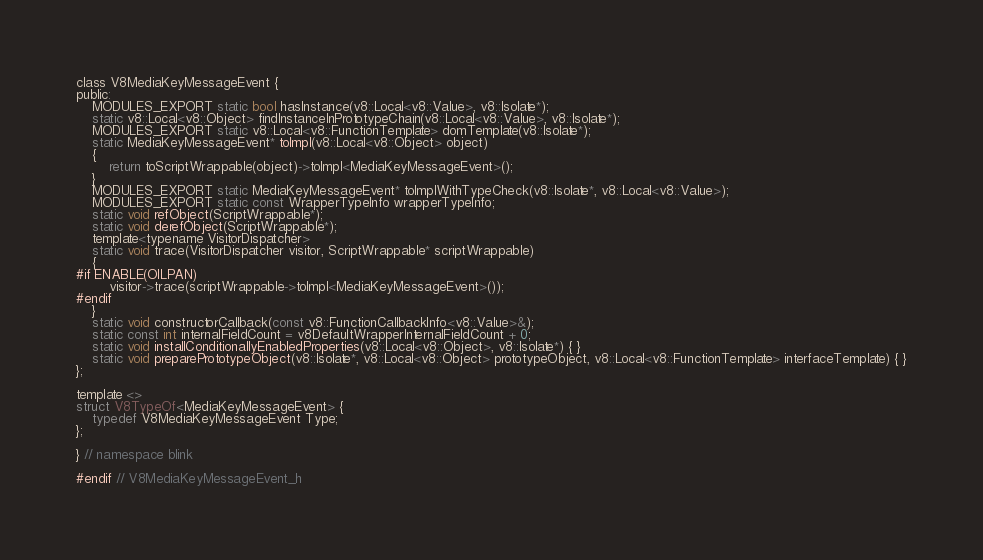Convert code to text. <code><loc_0><loc_0><loc_500><loc_500><_C_>class V8MediaKeyMessageEvent {
public:
    MODULES_EXPORT static bool hasInstance(v8::Local<v8::Value>, v8::Isolate*);
    static v8::Local<v8::Object> findInstanceInPrototypeChain(v8::Local<v8::Value>, v8::Isolate*);
    MODULES_EXPORT static v8::Local<v8::FunctionTemplate> domTemplate(v8::Isolate*);
    static MediaKeyMessageEvent* toImpl(v8::Local<v8::Object> object)
    {
        return toScriptWrappable(object)->toImpl<MediaKeyMessageEvent>();
    }
    MODULES_EXPORT static MediaKeyMessageEvent* toImplWithTypeCheck(v8::Isolate*, v8::Local<v8::Value>);
    MODULES_EXPORT static const WrapperTypeInfo wrapperTypeInfo;
    static void refObject(ScriptWrappable*);
    static void derefObject(ScriptWrappable*);
    template<typename VisitorDispatcher>
    static void trace(VisitorDispatcher visitor, ScriptWrappable* scriptWrappable)
    {
#if ENABLE(OILPAN)
        visitor->trace(scriptWrappable->toImpl<MediaKeyMessageEvent>());
#endif
    }
    static void constructorCallback(const v8::FunctionCallbackInfo<v8::Value>&);
    static const int internalFieldCount = v8DefaultWrapperInternalFieldCount + 0;
    static void installConditionallyEnabledProperties(v8::Local<v8::Object>, v8::Isolate*) { }
    static void preparePrototypeObject(v8::Isolate*, v8::Local<v8::Object> prototypeObject, v8::Local<v8::FunctionTemplate> interfaceTemplate) { }
};

template <>
struct V8TypeOf<MediaKeyMessageEvent> {
    typedef V8MediaKeyMessageEvent Type;
};

} // namespace blink

#endif // V8MediaKeyMessageEvent_h
</code> 